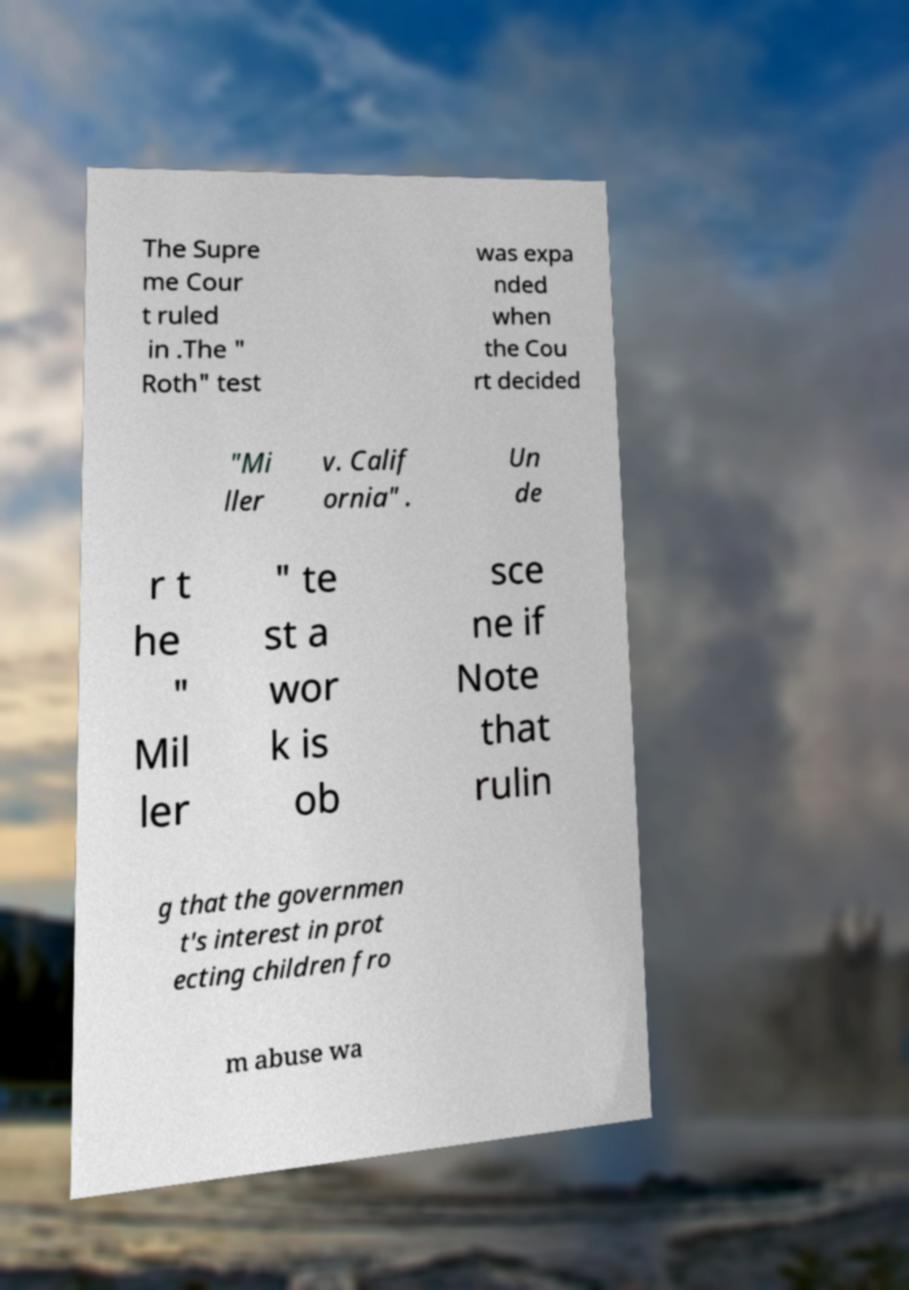Can you accurately transcribe the text from the provided image for me? The Supre me Cour t ruled in .The " Roth" test was expa nded when the Cou rt decided "Mi ller v. Calif ornia" . Un de r t he " Mil ler " te st a wor k is ob sce ne if Note that rulin g that the governmen t's interest in prot ecting children fro m abuse wa 